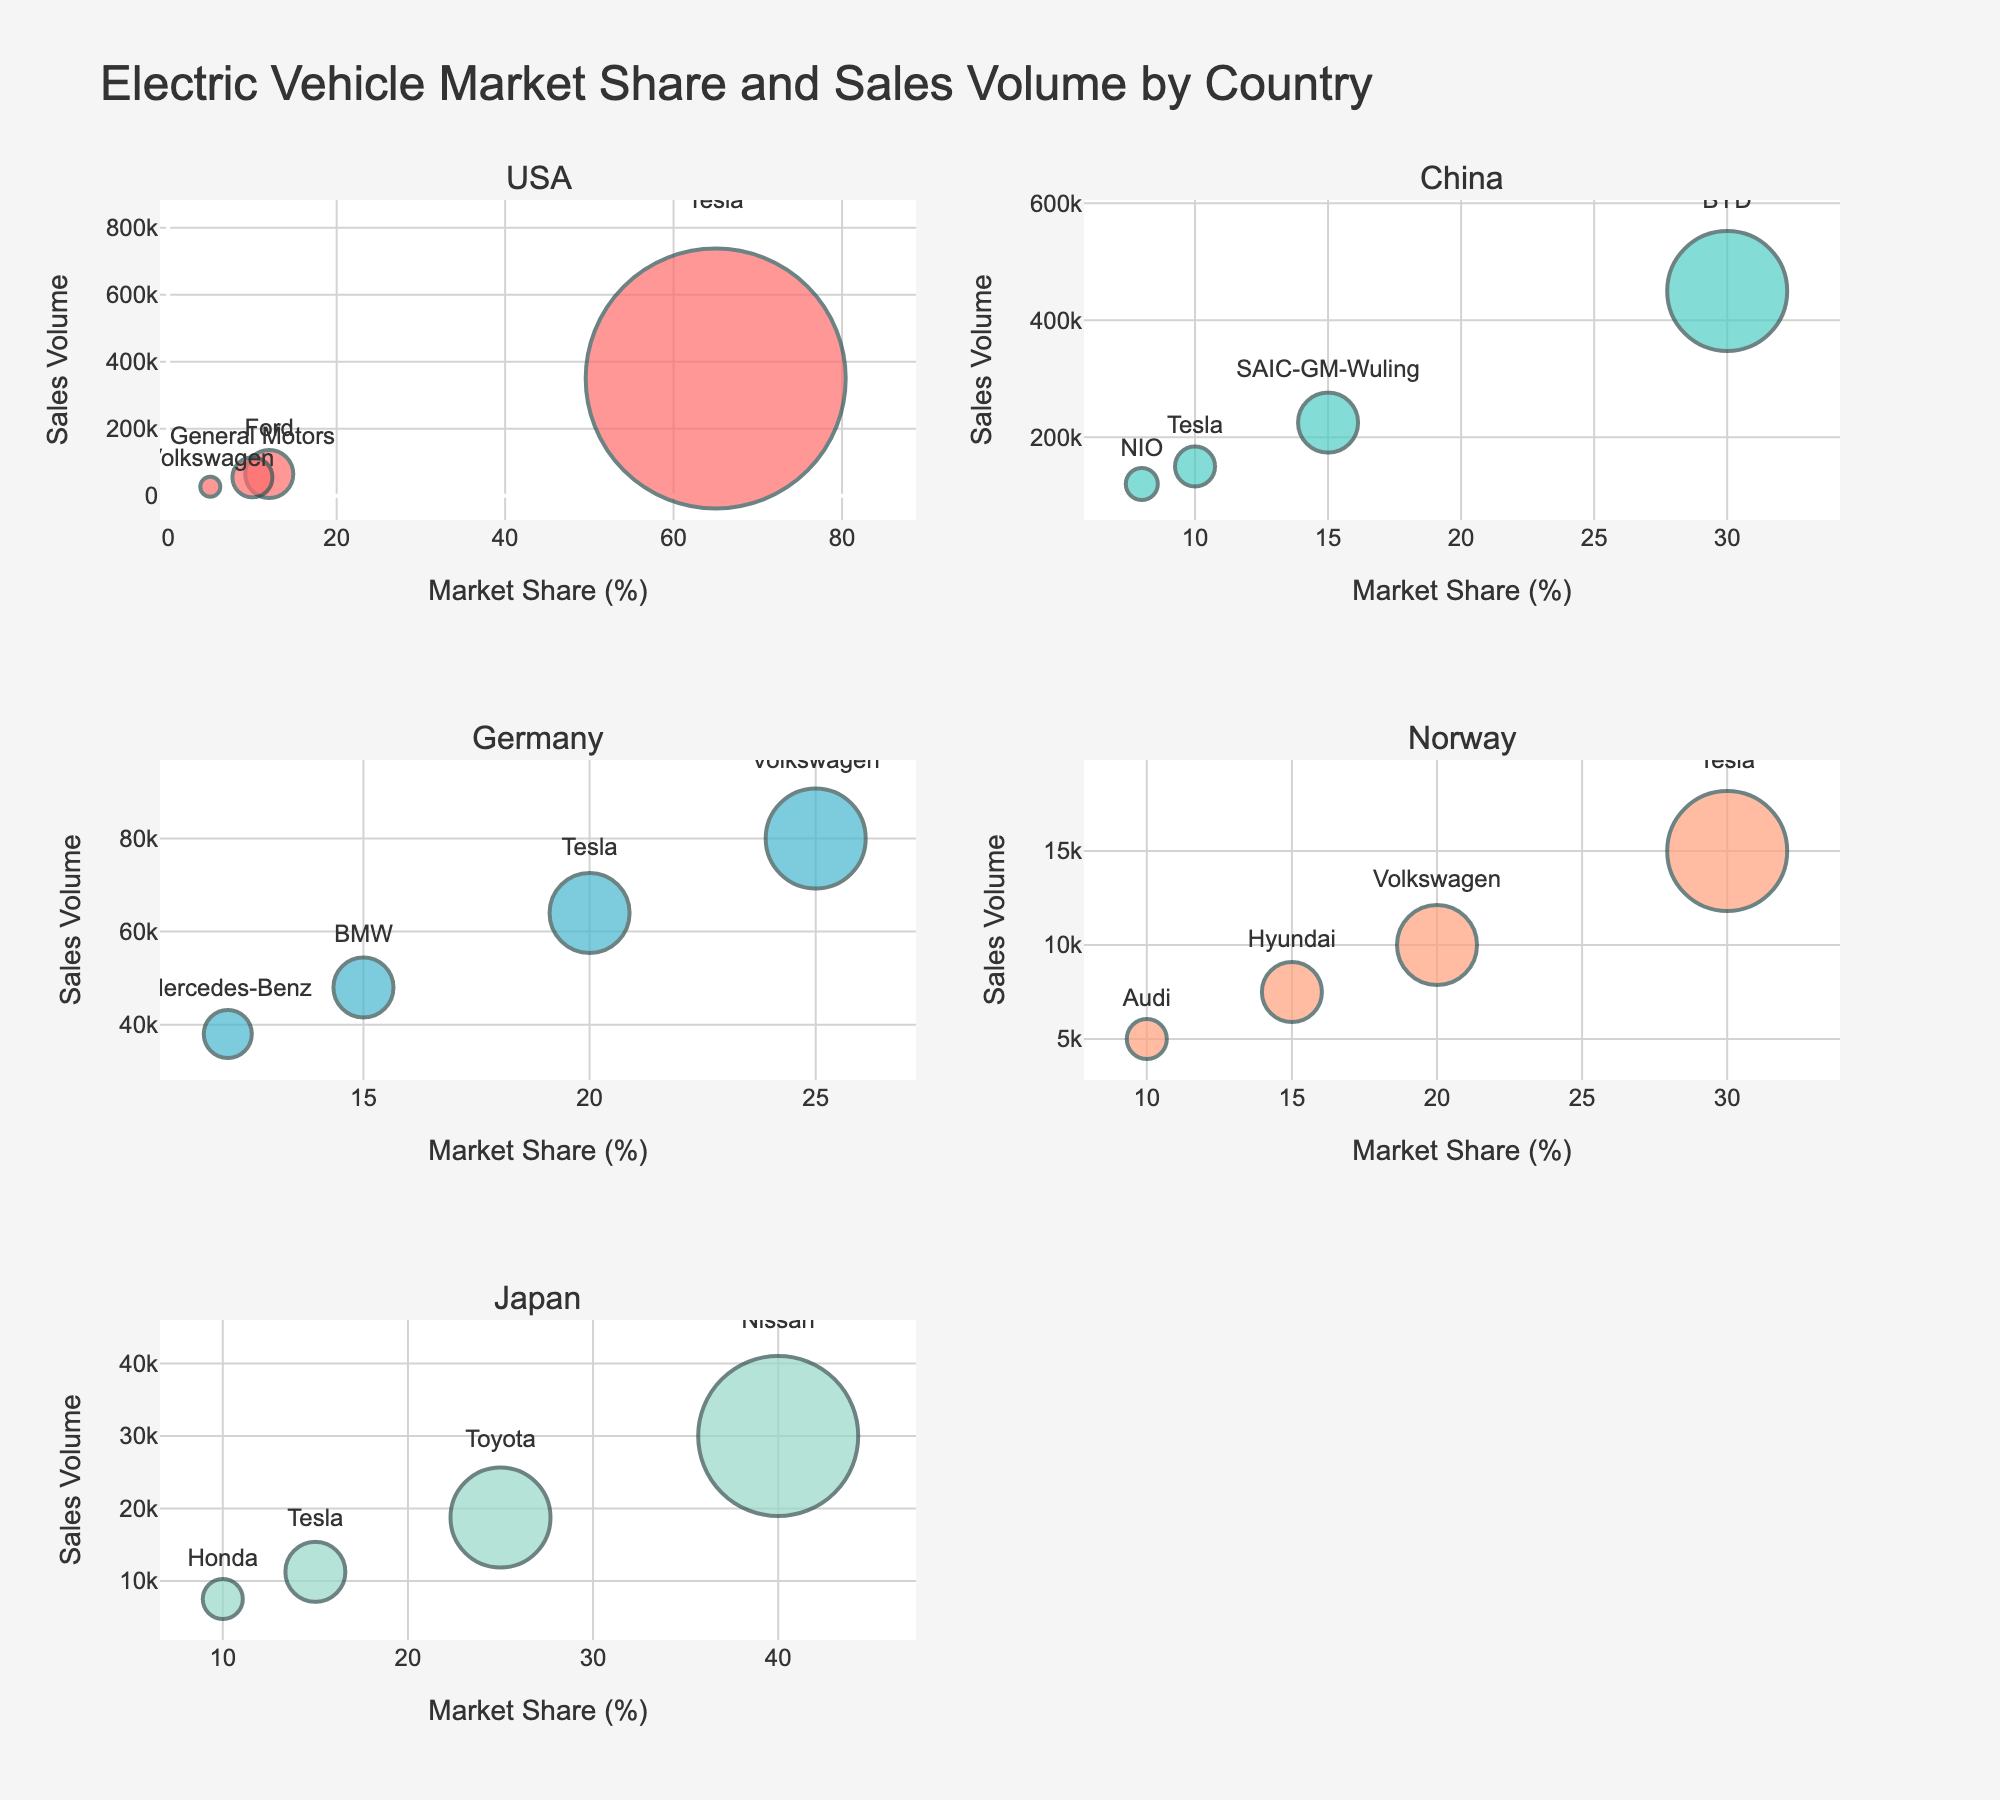What country has the highest sales volume of electric vehicles? The subplot shows the sales volumes for different countries. The highest sales volume can be observed in China under the highest bubble size, which is BYD.
Answer: China Which manufacturer has the largest market share in the USA? On the USA subplot, the largest bubble represents Tesla, showing the highest market share.
Answer: Tesla How does the market share of Tesla in Germany compare to Toyota in Japan? In the Germany subplot, Tesla has a market share of 20%. In the Japan subplot, Toyota has a market share of 25%. Therefore, Toyota has a 5% higher market share than Tesla in Japan.
Answer: Toyota has a higher market share What is the combined sales volume of manufacturers in Norway? From the Norway subplot, add the sales volumes: Tesla (15,000) + Volkswagen (10,000) + Hyundai (7,500) + Audi (5,000). The sum is 37,500 units.
Answer: 37,500 Of the manufacturers shown, which one has the smallest market share in any country, and in which country? The smallest market share in any subplot is Volkswagen in the USA with 5%.
Answer: Volkswagen, USA What is the total market share of Tesla across all the countries? Tesla is shown in the USA (65%), China (10%), Germany (20%), Norway (30%), and Japan (15%). Adding these values: 65% + 10% + 20% + 30% + 15% = 140%.
Answer: 140% Which country has the most diverse range of manufacturers (shown by number of unique manufacturers)? Count the number of different manufacturers in each country. USA has Tesla, Ford, General Motors, and Volkswagen (4); China has BYD, SAIC-GM-Wuling, Tesla, and NIO (4); Germany has Volkswagen, Tesla, BMW, and Mercedes-Benz (4); Norway has Tesla, Volkswagen, Hyundai, and Audi (4); Japan has Nissan, Toyota, Tesla, and Honda (4). All countries show 4 different manufacturers.
Answer: USA, China, Germany, Norway, Japan (all have 4) Does Ford have a higher sales volume than General Motors in the USA? In the USA subplot, Ford's sales volume is 65,000 units, and General Motors' sales volume is 55,000 units. Hence, Ford has a higher sales volume.
Answer: Yes What's the difference in market share between the largest and smallest market share in Germany? In the Germany subplot, the largest market share is Volkswagen (25%) and the smallest is Mercedes-Benz (12%). The difference is 25% - 12% = 13%.
Answer: 13% Which manufacturer's bubble appears largest in China? In the China subplot, the largest bubble, representing a 30% market share, is BYD.
Answer: BYD 